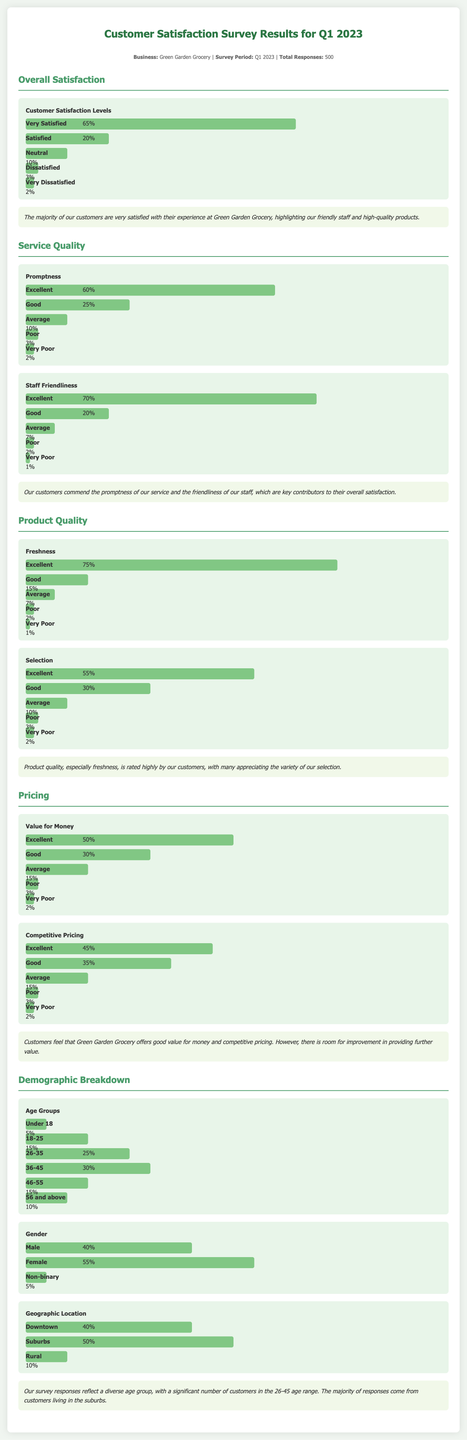What is the total number of survey responses? The document states that there were a total of 500 responses to the survey.
Answer: 500 What percentage of customers are very satisfied? The chart shows that 65% of customers reported being very satisfied.
Answer: 65% What is the percentage of customers who find product freshness excellent? According to the product quality section, 75% of customers rated product freshness as excellent.
Answer: 75% What is the competitive pricing percentage of respondents who rated it as excellent? The competitive pricing chart indicates that 45% of customers rated it as excellent.
Answer: 45% What demographic group has the highest percentage of respondents? The age group 36-45 has the highest percentage, at 30%.
Answer: 36-45 What is the percentage of male respondents? The gender demographic breakdown shows that 40% of respondents are male.
Answer: 40% What is the primary geographic location for survey respondents? The largest percentage of respondents, 50%, reported living in the suburbs.
Answer: Suburbs Which aspect of service quality received the highest rating? Staff friendliness received the highest rating with 70% of respondents rating it as excellent.
Answer: Staff Friendliness What is the least satisfied category among customers? The least satisfied category is Very Dissatisfied, with only 2% of respondents indicating this.
Answer: 2% 